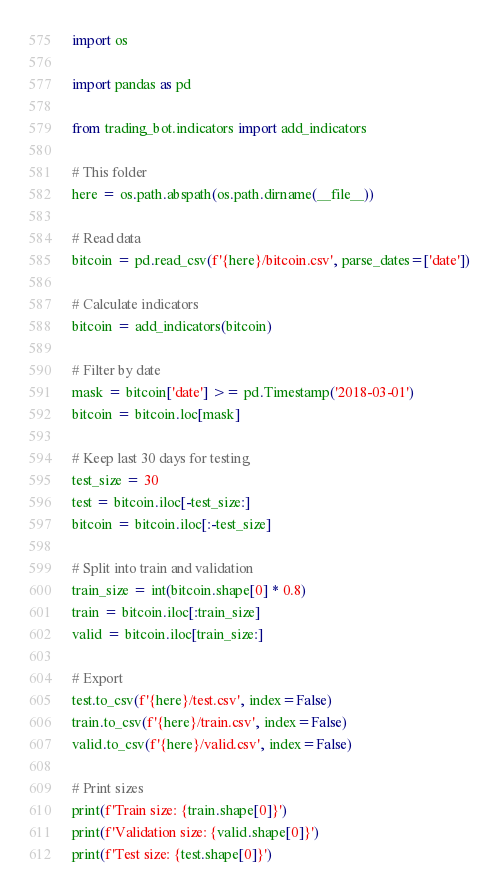<code> <loc_0><loc_0><loc_500><loc_500><_Python_>import os

import pandas as pd

from trading_bot.indicators import add_indicators

# This folder
here = os.path.abspath(os.path.dirname(__file__))

# Read data
bitcoin = pd.read_csv(f'{here}/bitcoin.csv', parse_dates=['date'])

# Calculate indicators
bitcoin = add_indicators(bitcoin)

# Filter by date
mask = bitcoin['date'] >= pd.Timestamp('2018-03-01')
bitcoin = bitcoin.loc[mask]

# Keep last 30 days for testing
test_size = 30
test = bitcoin.iloc[-test_size:]
bitcoin = bitcoin.iloc[:-test_size]

# Split into train and validation
train_size = int(bitcoin.shape[0] * 0.8)
train = bitcoin.iloc[:train_size]
valid = bitcoin.iloc[train_size:]

# Export
test.to_csv(f'{here}/test.csv', index=False)
train.to_csv(f'{here}/train.csv', index=False)
valid.to_csv(f'{here}/valid.csv', index=False)

# Print sizes
print(f'Train size: {train.shape[0]}')
print(f'Validation size: {valid.shape[0]}')
print(f'Test size: {test.shape[0]}')
</code> 